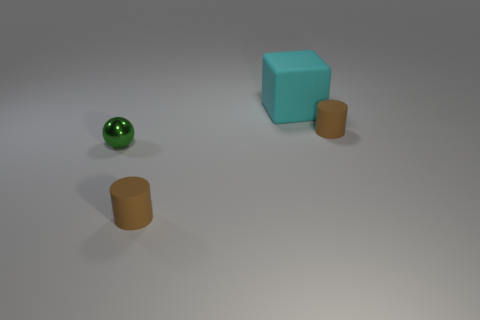Are there more cylinders that are to the left of the big cyan matte cube than tiny brown cylinders? Based on the visual elements in the image, there are an equal number of cylinders on the left side of the big cyan matte cube when compared to the count of tiny brown cylinders in the scene. 